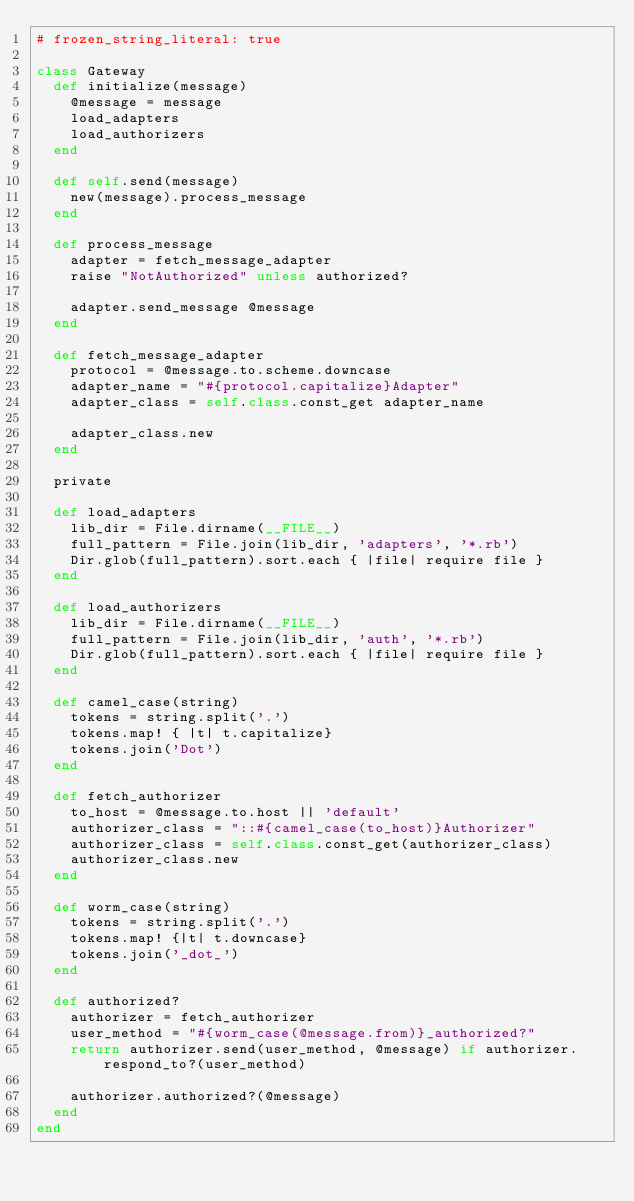Convert code to text. <code><loc_0><loc_0><loc_500><loc_500><_Ruby_># frozen_string_literal: true

class Gateway
  def initialize(message)
    @message = message
    load_adapters
    load_authorizers
  end

  def self.send(message)
    new(message).process_message
  end

  def process_message
    adapter = fetch_message_adapter
    raise "NotAuthorized" unless authorized?

    adapter.send_message @message
  end

  def fetch_message_adapter
    protocol = @message.to.scheme.downcase
    adapter_name = "#{protocol.capitalize}Adapter"
    adapter_class = self.class.const_get adapter_name

    adapter_class.new
  end

  private

  def load_adapters
    lib_dir = File.dirname(__FILE__)
    full_pattern = File.join(lib_dir, 'adapters', '*.rb')
    Dir.glob(full_pattern).sort.each { |file| require file }
  end

  def load_authorizers
    lib_dir = File.dirname(__FILE__)
    full_pattern = File.join(lib_dir, 'auth', '*.rb')
    Dir.glob(full_pattern).sort.each { |file| require file }
  end

  def camel_case(string)
    tokens = string.split('.')
    tokens.map! { |t| t.capitalize}
    tokens.join('Dot')
  end

  def fetch_authorizer
    to_host = @message.to.host || 'default'
    authorizer_class = "::#{camel_case(to_host)}Authorizer"
    authorizer_class = self.class.const_get(authorizer_class)
    authorizer_class.new
  end

  def worm_case(string)
    tokens = string.split('.')
    tokens.map! {|t| t.downcase}
    tokens.join('_dot_')
  end

  def authorized?
    authorizer = fetch_authorizer
    user_method = "#{worm_case(@message.from)}_authorized?"
    return authorizer.send(user_method, @message) if authorizer.respond_to?(user_method)

    authorizer.authorized?(@message)
  end
end
</code> 